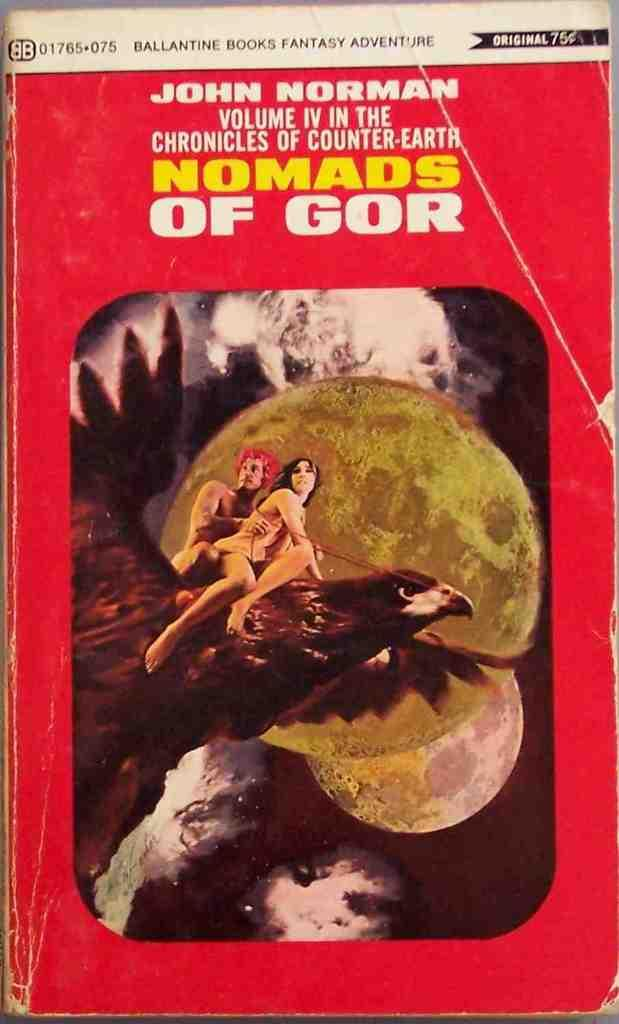<image>
Create a compact narrative representing the image presented. The cover of the book Normads of Gor features a man and woman riding a giant bird. 